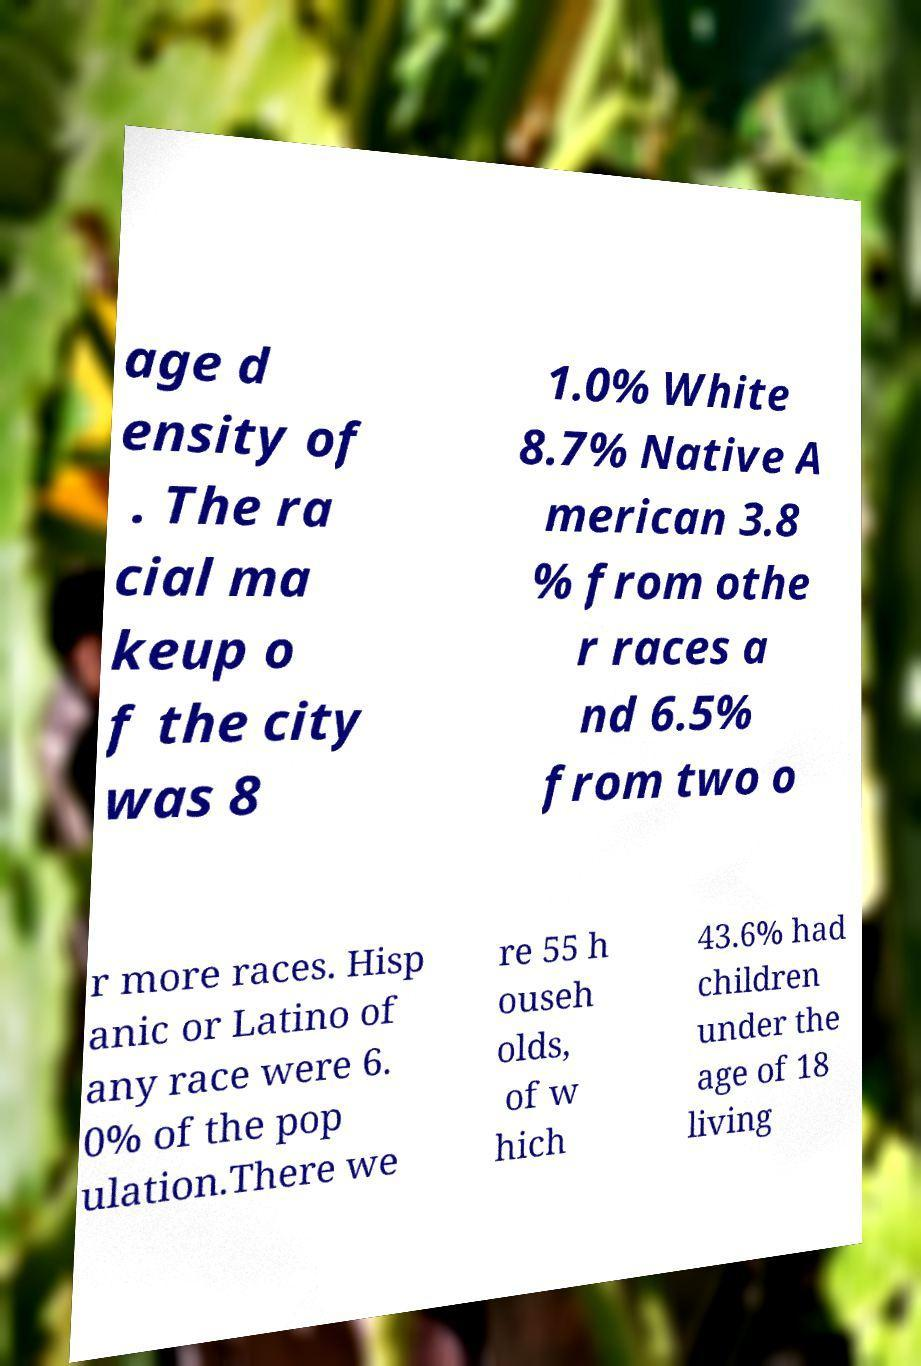Please identify and transcribe the text found in this image. age d ensity of . The ra cial ma keup o f the city was 8 1.0% White 8.7% Native A merican 3.8 % from othe r races a nd 6.5% from two o r more races. Hisp anic or Latino of any race were 6. 0% of the pop ulation.There we re 55 h ouseh olds, of w hich 43.6% had children under the age of 18 living 